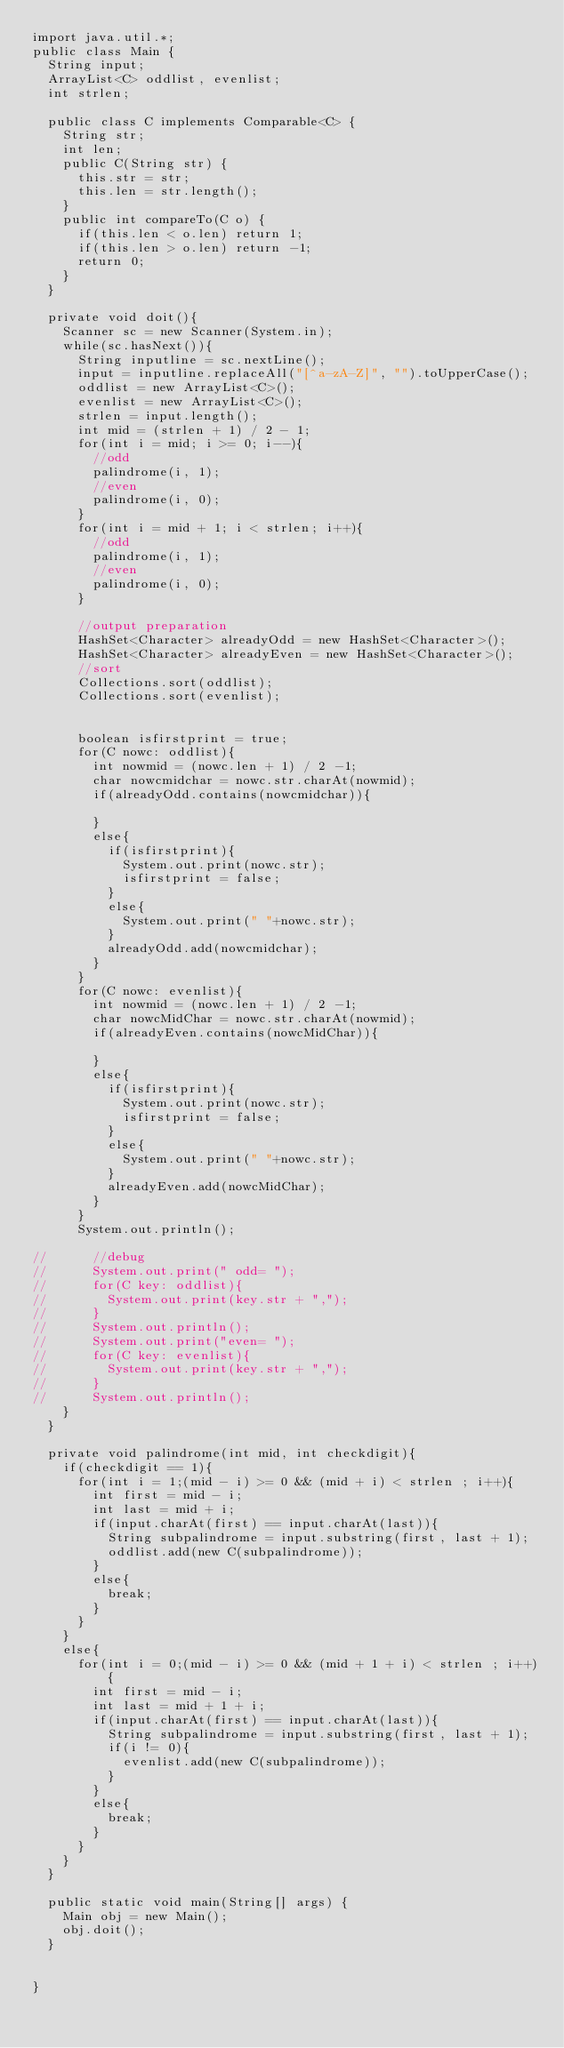Convert code to text. <code><loc_0><loc_0><loc_500><loc_500><_Java_>import java.util.*;
public class Main {
	String input;
	ArrayList<C> oddlist, evenlist;
	int strlen;
	
	public class C implements Comparable<C> {
		String str;
		int len;
		public C(String str) {
			this.str = str;
			this.len = str.length();
		}
		public int compareTo(C o) {
			if(this.len < o.len) return 1;
			if(this.len > o.len) return -1;
			return 0;
		}
	}
	
	private void doit(){
		Scanner sc = new Scanner(System.in);
		while(sc.hasNext()){
			String inputline = sc.nextLine();
			input = inputline.replaceAll("[^a-zA-Z]", "").toUpperCase();
			oddlist = new ArrayList<C>();
			evenlist = new ArrayList<C>();
			strlen = input.length();
			int mid = (strlen + 1) / 2 - 1;
			for(int i = mid; i >= 0; i--){
				//odd
				palindrome(i, 1);
				//even
				palindrome(i, 0);
			}
			for(int i = mid + 1; i < strlen; i++){
				//odd
				palindrome(i, 1);
				//even
				palindrome(i, 0);
			}
			
			//output preparation
			HashSet<Character> alreadyOdd = new HashSet<Character>();
			HashSet<Character> alreadyEven = new HashSet<Character>();
			//sort
			Collections.sort(oddlist);
			Collections.sort(evenlist);
			
			
			boolean isfirstprint = true;
			for(C nowc: oddlist){
				int nowmid = (nowc.len + 1) / 2 -1;
				char nowcmidchar = nowc.str.charAt(nowmid);
				if(alreadyOdd.contains(nowcmidchar)){
					
				}
				else{
					if(isfirstprint){
						System.out.print(nowc.str);
						isfirstprint = false;
					}
					else{
						System.out.print(" "+nowc.str);
					}
					alreadyOdd.add(nowcmidchar);
				}
			}
			for(C nowc: evenlist){
				int nowmid = (nowc.len + 1) / 2 -1;
				char nowcMidChar = nowc.str.charAt(nowmid);
				if(alreadyEven.contains(nowcMidChar)){
					
				}
				else{
					if(isfirstprint){
						System.out.print(nowc.str);
						isfirstprint = false;
					}
					else{
						System.out.print(" "+nowc.str);
					}
					alreadyEven.add(nowcMidChar);
				}
			}
			System.out.println();
			
//			//debug
//			System.out.print(" odd= ");
//			for(C key: oddlist){
//				System.out.print(key.str + ",");
//			}
//			System.out.println();
//			System.out.print("even= ");
//			for(C key: evenlist){
//				System.out.print(key.str + ",");
//			}
//			System.out.println();
		}
	}
	
	private void palindrome(int mid, int checkdigit){
		if(checkdigit == 1){
			for(int i = 1;(mid - i) >= 0 && (mid + i) < strlen ; i++){
				int first = mid - i;
				int last = mid + i;
				if(input.charAt(first) == input.charAt(last)){
					String subpalindrome = input.substring(first, last + 1);
					oddlist.add(new C(subpalindrome));
				}
				else{
					break;
				}
			}
		}
		else{
			for(int i = 0;(mid - i) >= 0 && (mid + 1 + i) < strlen ; i++){
				int first = mid - i;
				int last = mid + 1 + i;
				if(input.charAt(first) == input.charAt(last)){
					String subpalindrome = input.substring(first, last + 1);
					if(i != 0){
						evenlist.add(new C(subpalindrome));
					}
				}
				else{
					break;
				}
			}
		}
	}

	public static void main(String[] args) {
		Main obj = new Main();
		obj.doit();
	}
	
	
}</code> 